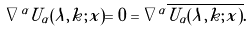<formula> <loc_0><loc_0><loc_500><loc_500>\nabla ^ { \alpha } U _ { \alpha } ( \lambda , { k } ; { x } ) = 0 = \nabla ^ { \alpha } \overline { U _ { \alpha } ( \lambda , { k } ; { x } ) } .</formula> 